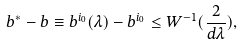<formula> <loc_0><loc_0><loc_500><loc_500>b ^ { * } - b \equiv b ^ { i _ { 0 } } ( \lambda ) - b ^ { i _ { 0 } } \leq W ^ { - 1 } ( \frac { 2 } { d \lambda } ) ,</formula> 